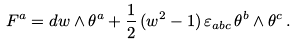<formula> <loc_0><loc_0><loc_500><loc_500>F ^ { a } = d w \wedge \theta ^ { a } + \frac { 1 } { 2 } \, ( w ^ { 2 } - 1 ) \, \varepsilon _ { a b c } \, \theta ^ { b } \wedge \theta ^ { c } \, .</formula> 